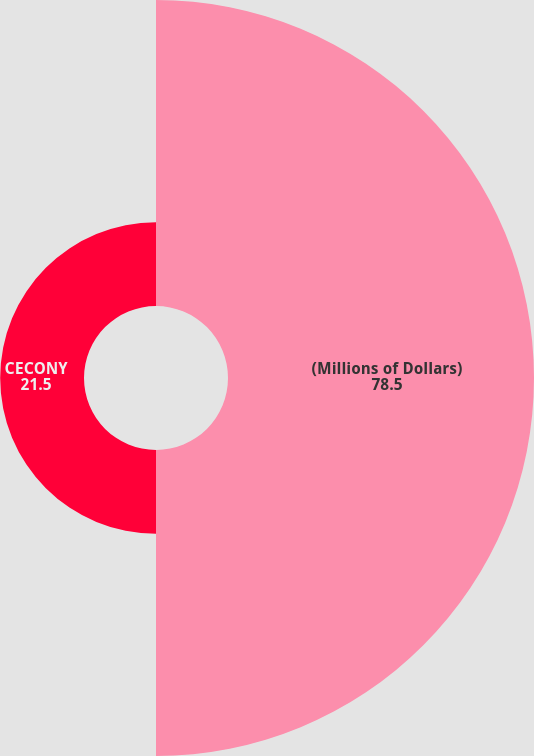Convert chart. <chart><loc_0><loc_0><loc_500><loc_500><pie_chart><fcel>(Millions of Dollars)<fcel>CECONY<nl><fcel>78.5%<fcel>21.5%<nl></chart> 